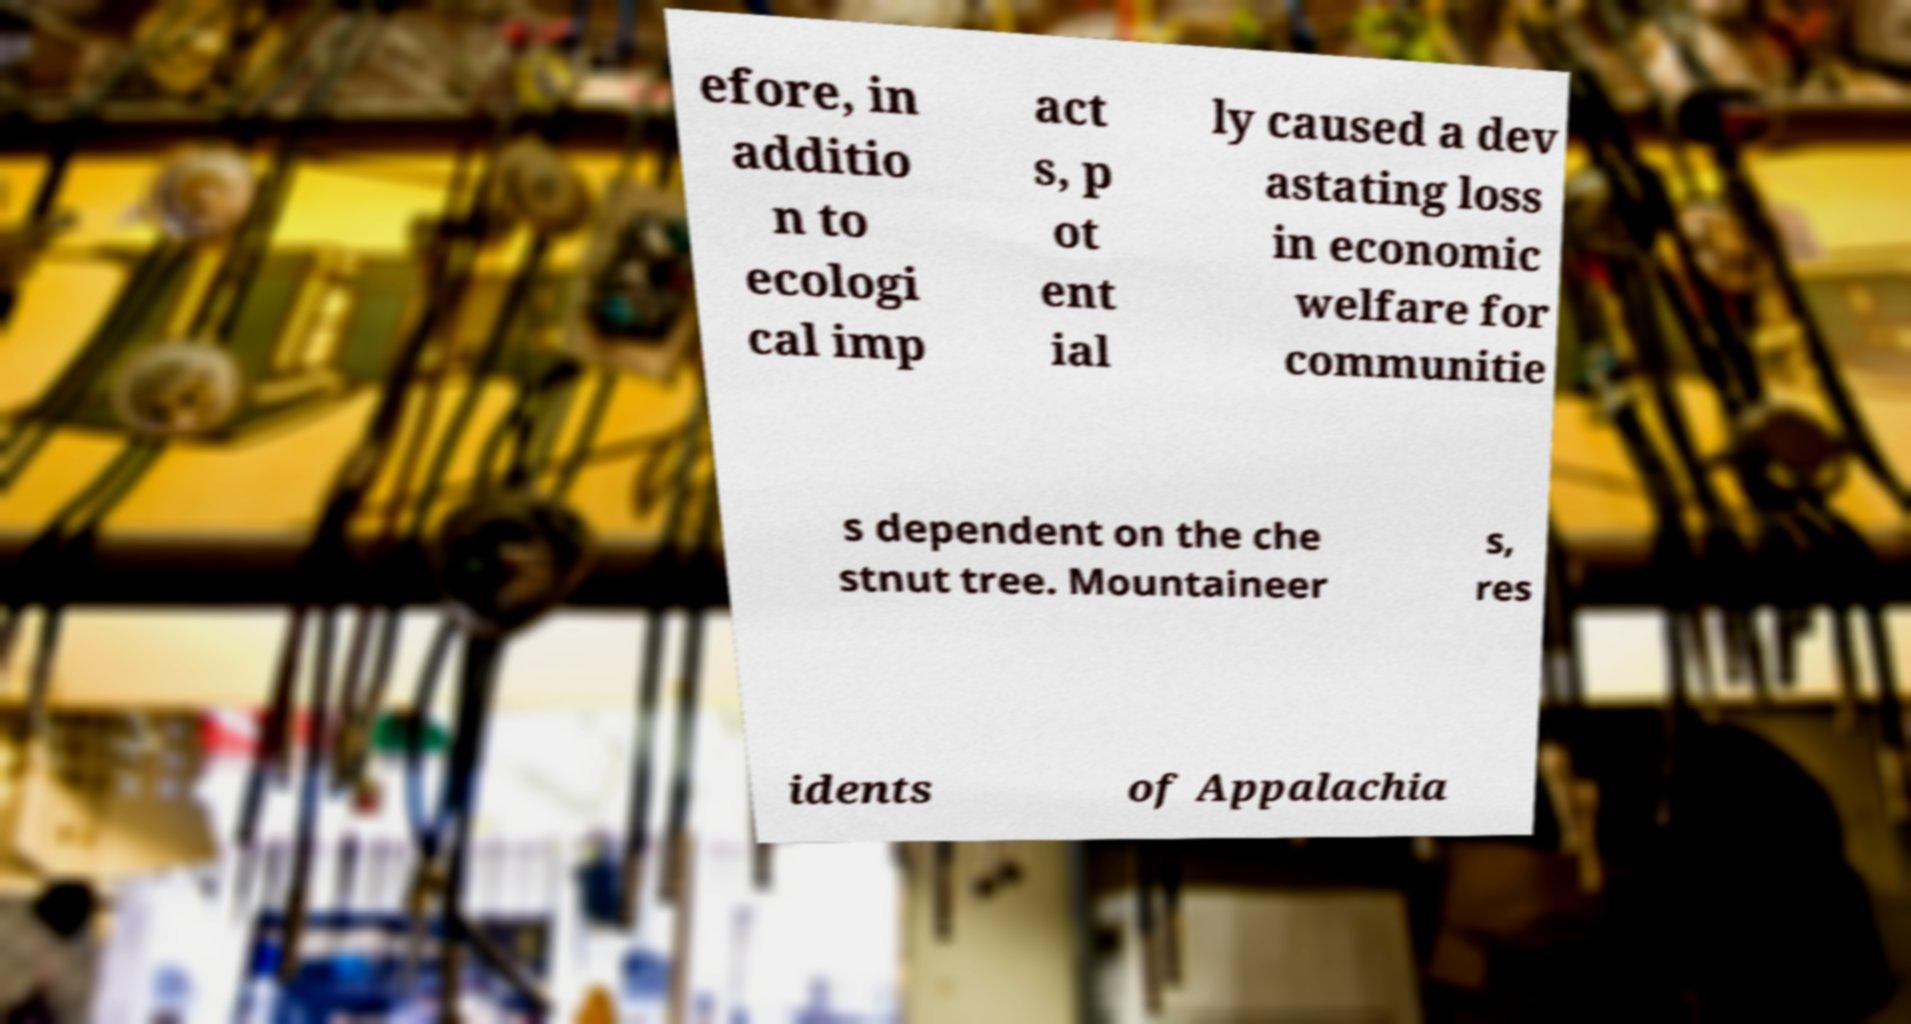Could you assist in decoding the text presented in this image and type it out clearly? efore, in additio n to ecologi cal imp act s, p ot ent ial ly caused a dev astating loss in economic welfare for communitie s dependent on the che stnut tree. Mountaineer s, res idents of Appalachia 